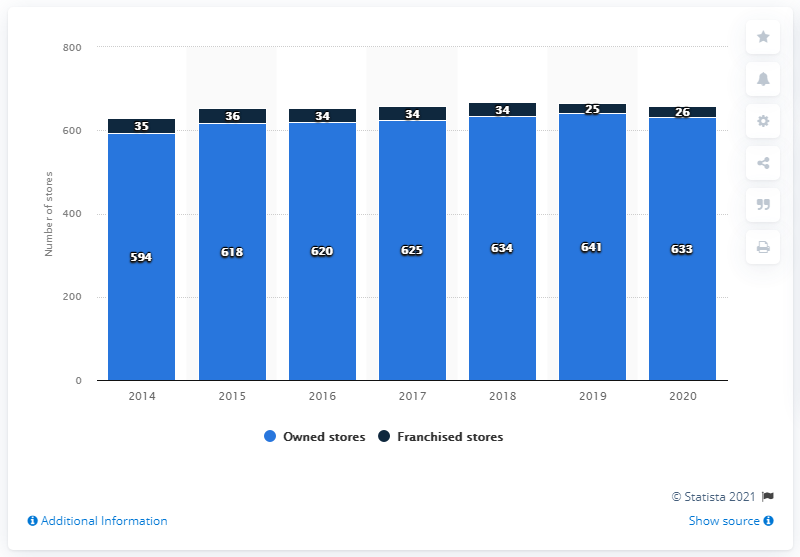Specify some key components in this picture. In 2020, Prada operated a total of 26 franchised stores. In 2020, Prada operated 633 stores worldwide. 